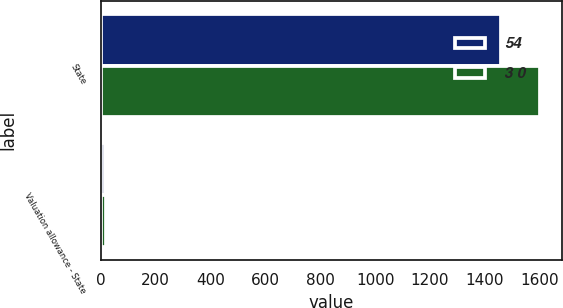Convert chart. <chart><loc_0><loc_0><loc_500><loc_500><stacked_bar_chart><ecel><fcel>State<fcel>Valuation allowance - State<nl><fcel>54<fcel>1460<fcel>14<nl><fcel>3 0<fcel>1600<fcel>21<nl></chart> 